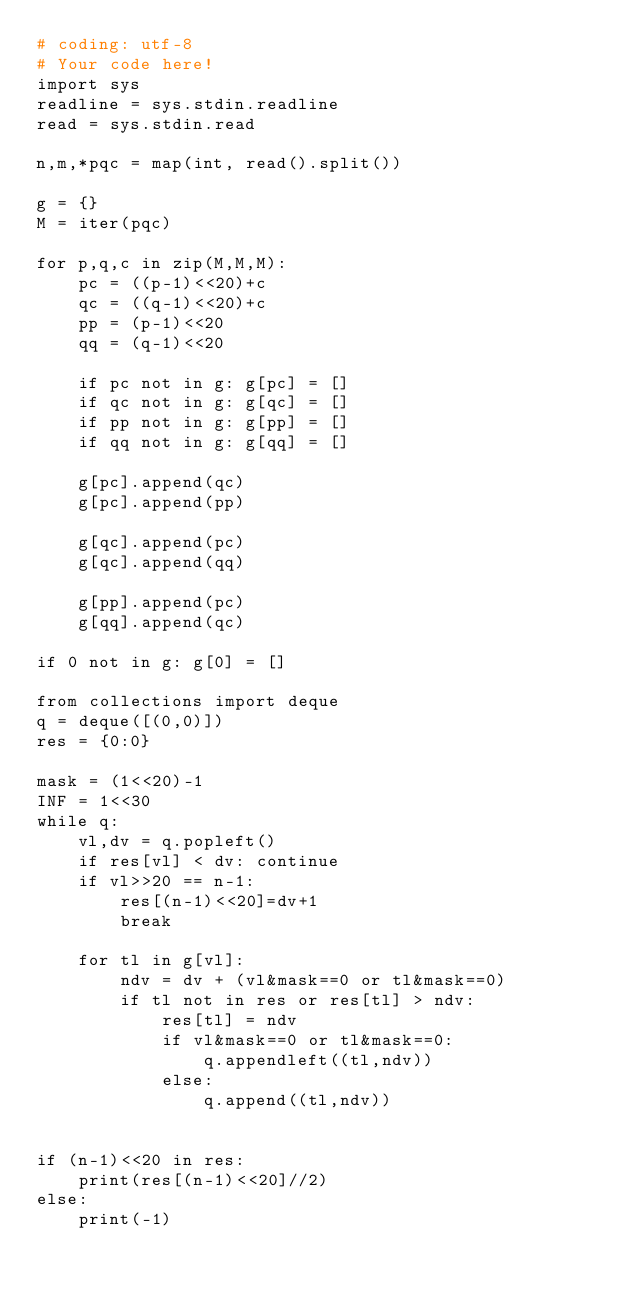Convert code to text. <code><loc_0><loc_0><loc_500><loc_500><_Python_># coding: utf-8
# Your code here!
import sys
readline = sys.stdin.readline
read = sys.stdin.read

n,m,*pqc = map(int, read().split())

g = {}
M = iter(pqc)

for p,q,c in zip(M,M,M):
    pc = ((p-1)<<20)+c
    qc = ((q-1)<<20)+c
    pp = (p-1)<<20
    qq = (q-1)<<20
    
    if pc not in g: g[pc] = []
    if qc not in g: g[qc] = []
    if pp not in g: g[pp] = []
    if qq not in g: g[qq] = []
    
    g[pc].append(qc)
    g[pc].append(pp)

    g[qc].append(pc)
    g[qc].append(qq)

    g[pp].append(pc)
    g[qq].append(qc)

if 0 not in g: g[0] = []

from collections import deque
q = deque([(0,0)])
res = {0:0}

mask = (1<<20)-1
INF = 1<<30
while q:
    vl,dv = q.popleft()
    if res[vl] < dv: continue
    if vl>>20 == n-1:
        res[(n-1)<<20]=dv+1
        break

    for tl in g[vl]:
        ndv = dv + (vl&mask==0 or tl&mask==0)
        if tl not in res or res[tl] > ndv:
            res[tl] = ndv
            if vl&mask==0 or tl&mask==0:
                q.appendleft((tl,ndv))
            else:
                q.append((tl,ndv))
            

if (n-1)<<20 in res:
    print(res[(n-1)<<20]//2)
else:
    print(-1)




</code> 